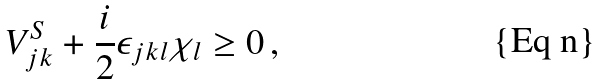<formula> <loc_0><loc_0><loc_500><loc_500>V _ { j k } ^ { S } + \frac { i } { 2 } \epsilon _ { j k l } \chi _ { l } \geq 0 \, ,</formula> 